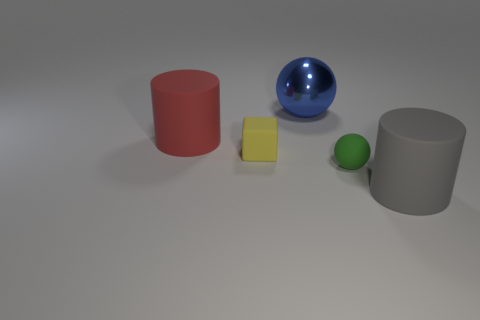If these objects were part of an art installation, what do you think the theme might be? The theme might revolve around geometry and balance. Each object represents a primary shape - cylinder, cube, sphere, and demonstrates how fundamental geometric forms can interact with each other and the space around them, creating a harmonious and minimalistic display. 